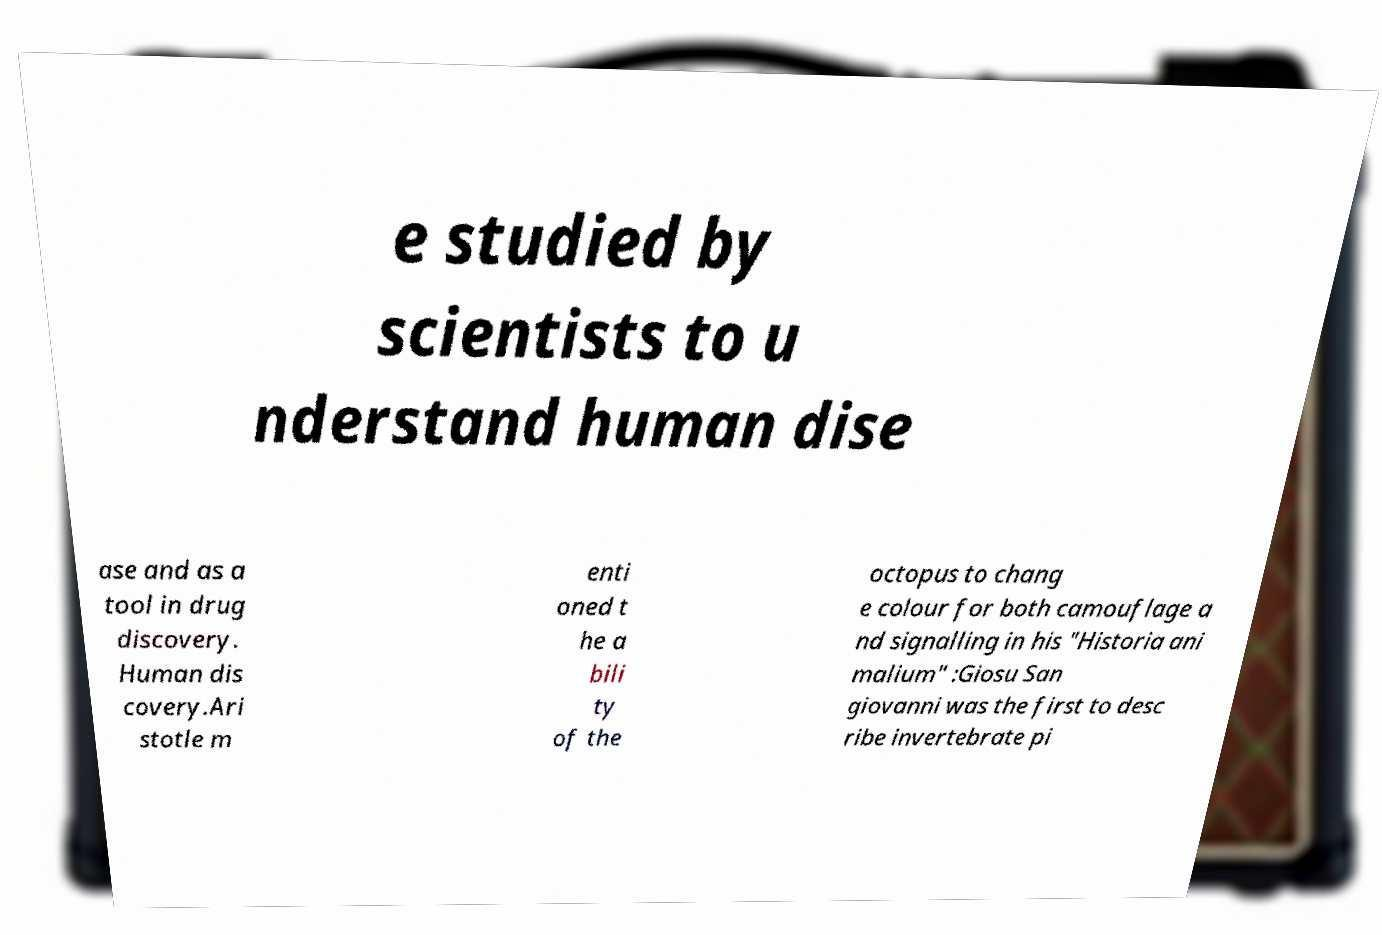There's text embedded in this image that I need extracted. Can you transcribe it verbatim? e studied by scientists to u nderstand human dise ase and as a tool in drug discovery. Human dis covery.Ari stotle m enti oned t he a bili ty of the octopus to chang e colour for both camouflage a nd signalling in his "Historia ani malium" :Giosu San giovanni was the first to desc ribe invertebrate pi 